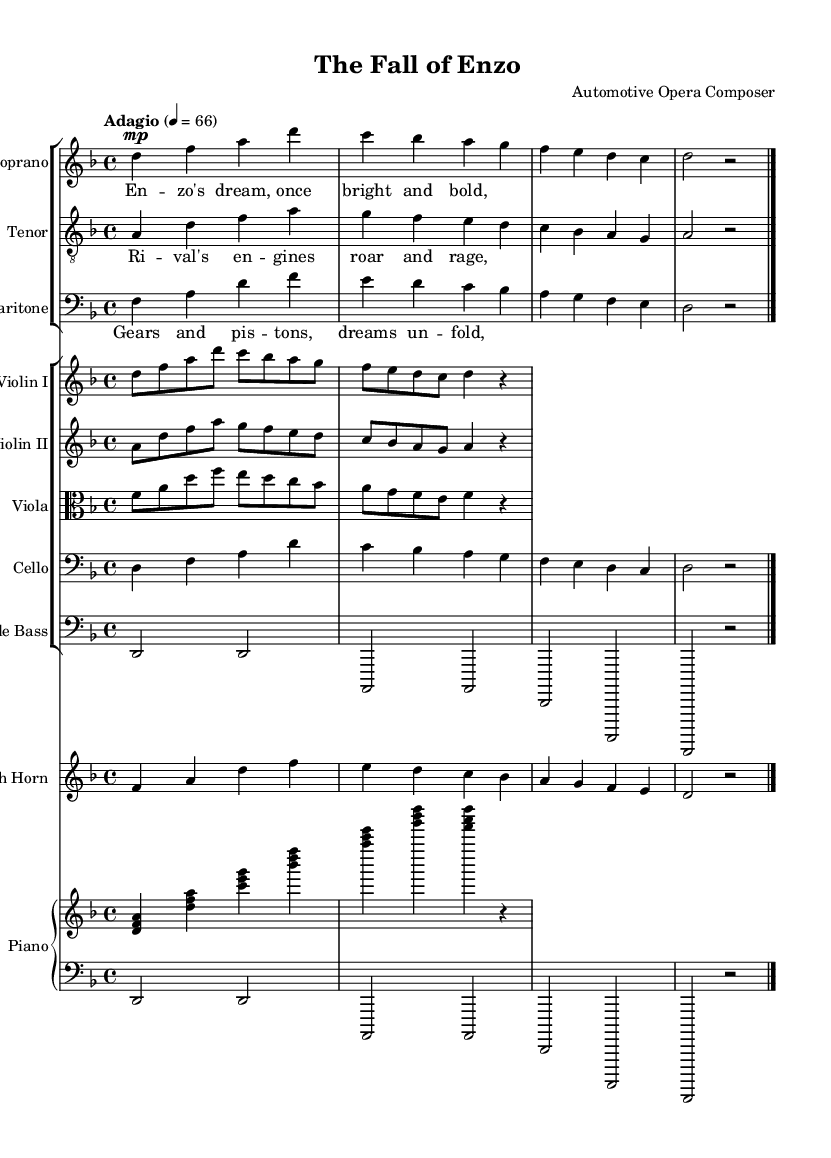What is the key signature of this music? The key signature is indicated at the beginning of the score and shows two flats, which corresponds to D minor.
Answer: D minor What is the time signature of this piece? The time signature is indicated as 4/4 at the beginning of the score, which means there are four beats in each measure.
Answer: 4/4 What is the tempo marking for the piece? The tempo marking is stated at the beginning of the score as "Adagio," which typically indicates a slow tempo.
Answer: Adagio How many staves are used for the vocal parts? There are three staves used for the vocal parts: soprano, tenor, and baritone, as noted in the staff groupings.
Answer: Three What is the first note sung by the soprano? The first note sung by the soprano is D, which is indicated in the melody line shown on the staff.
Answer: D Which two instruments play the same rhythm in the introduction? The violins (both I and II) play the same rhythm in the introduction, as seen in their respective parts.
Answer: Violins I and II What is the theme of the opera as suggested by the lyrics? The lyrics indicate a theme focused on Enzo's dreams and the struggles related to automotive design and innovation.
Answer: Enzo's dreams 